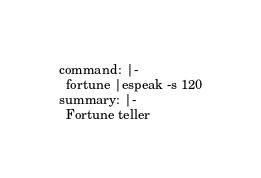<code> <loc_0><loc_0><loc_500><loc_500><_YAML_>command: |-
  fortune |espeak -s 120
summary: |-
  Fortune teller
</code> 